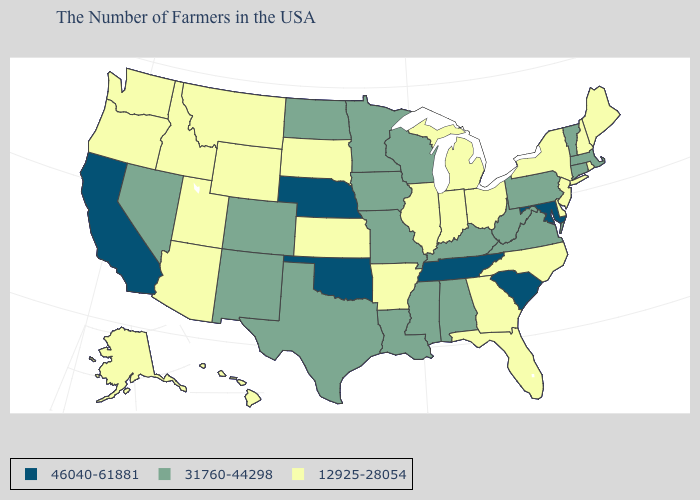What is the value of Massachusetts?
Keep it brief. 31760-44298. Which states have the lowest value in the MidWest?
Concise answer only. Ohio, Michigan, Indiana, Illinois, Kansas, South Dakota. What is the highest value in the USA?
Be succinct. 46040-61881. Is the legend a continuous bar?
Write a very short answer. No. What is the lowest value in the Northeast?
Write a very short answer. 12925-28054. What is the highest value in the USA?
Be succinct. 46040-61881. Among the states that border Maryland , which have the lowest value?
Give a very brief answer. Delaware. What is the value of Tennessee?
Be succinct. 46040-61881. What is the value of West Virginia?
Quick response, please. 31760-44298. What is the value of South Carolina?
Short answer required. 46040-61881. Does New Hampshire have the highest value in the Northeast?
Be succinct. No. Among the states that border Wisconsin , does Michigan have the highest value?
Concise answer only. No. What is the value of Alaska?
Keep it brief. 12925-28054. How many symbols are there in the legend?
Give a very brief answer. 3. Does the map have missing data?
Be succinct. No. 